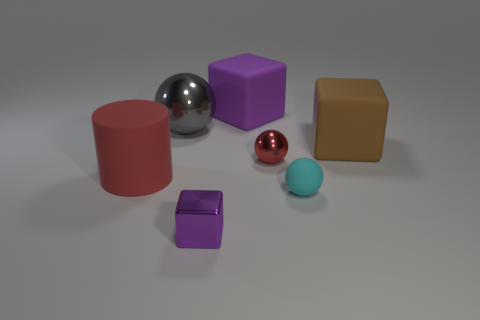There is a red object that is on the right side of the thing that is behind the big metal object; what is its shape? sphere 